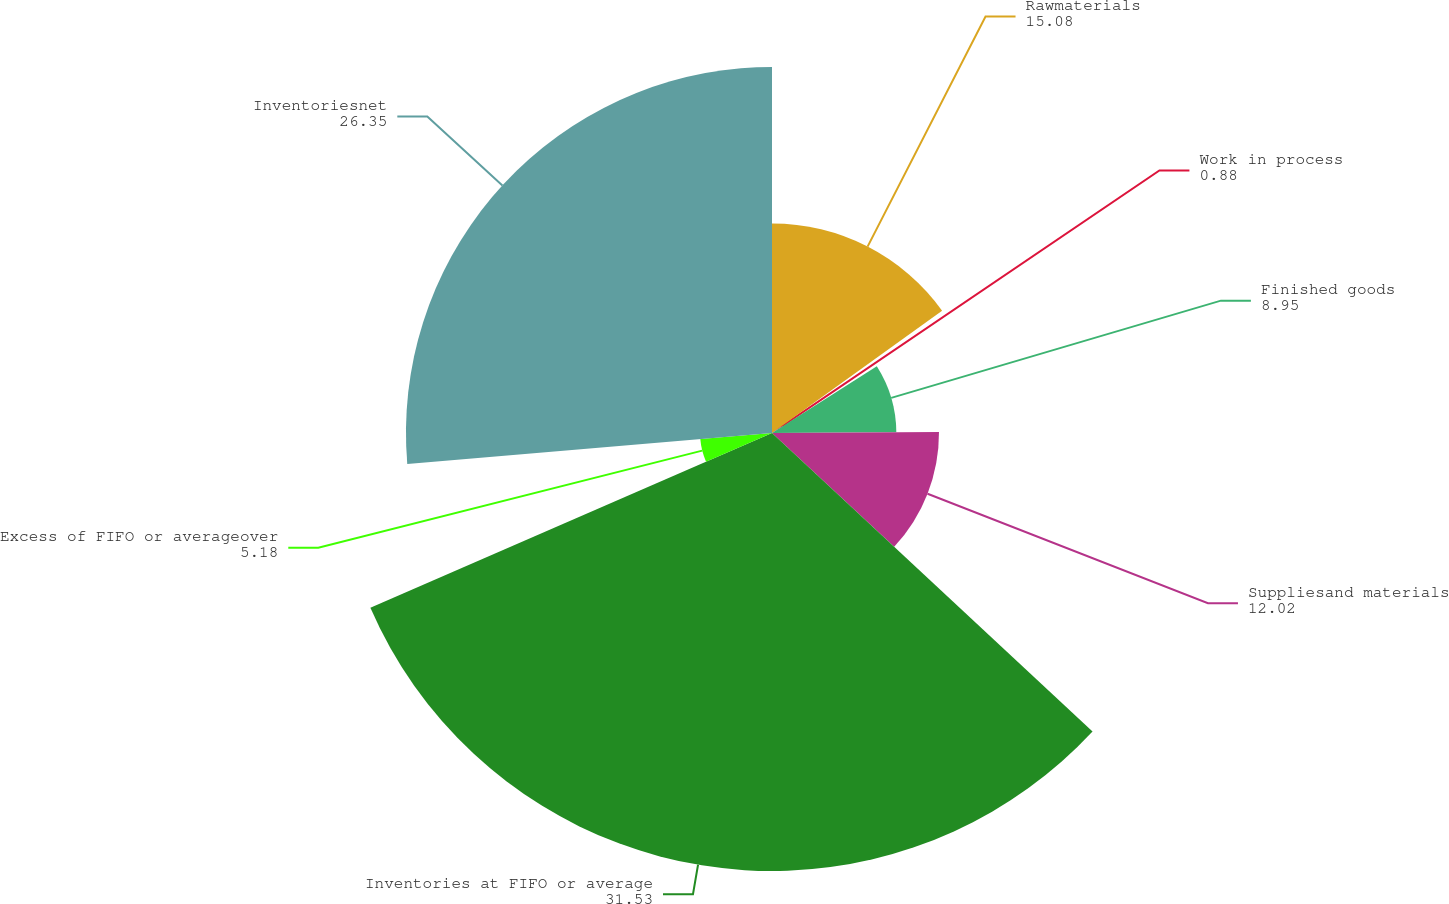Convert chart. <chart><loc_0><loc_0><loc_500><loc_500><pie_chart><fcel>Rawmaterials<fcel>Work in process<fcel>Finished goods<fcel>Suppliesand materials<fcel>Inventories at FIFO or average<fcel>Excess of FIFO or averageover<fcel>Inventoriesnet<nl><fcel>15.08%<fcel>0.88%<fcel>8.95%<fcel>12.02%<fcel>31.53%<fcel>5.18%<fcel>26.35%<nl></chart> 